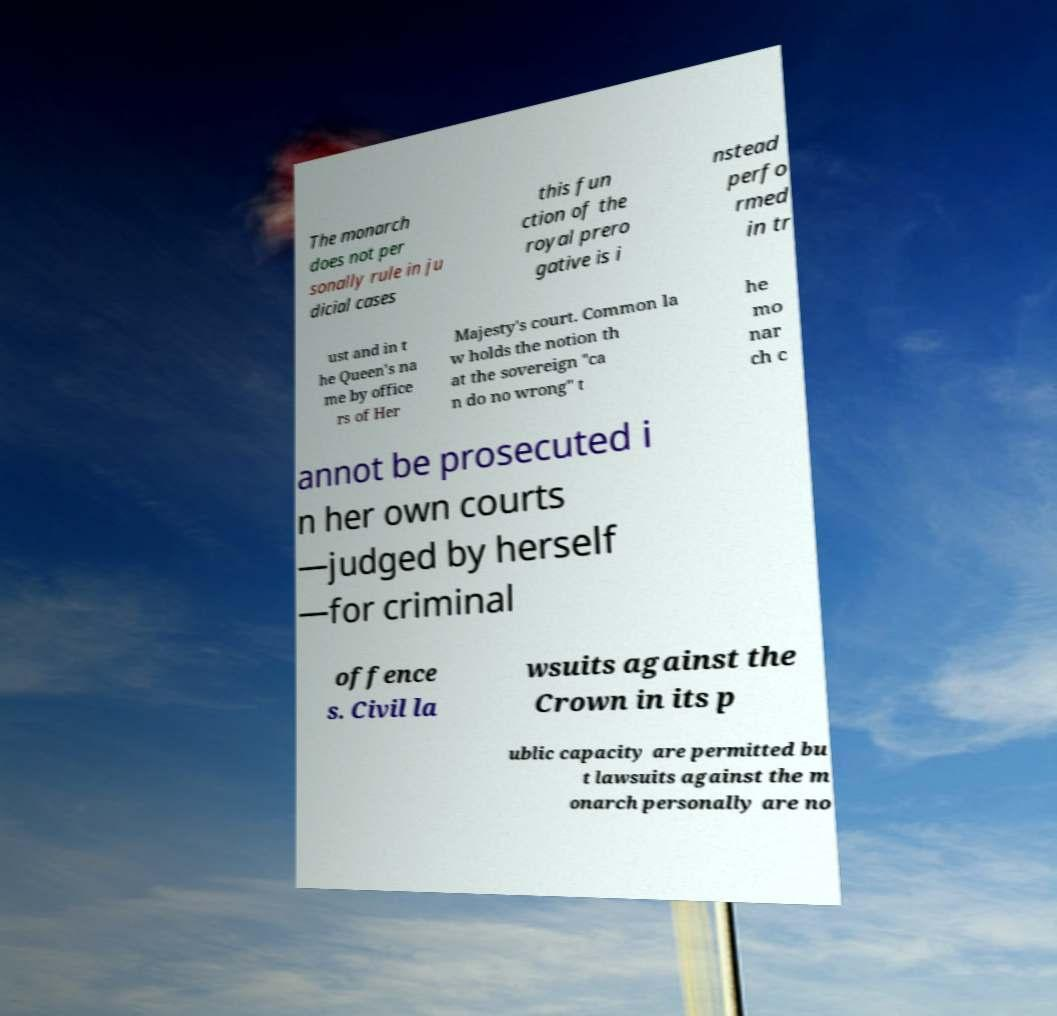I need the written content from this picture converted into text. Can you do that? The monarch does not per sonally rule in ju dicial cases this fun ction of the royal prero gative is i nstead perfo rmed in tr ust and in t he Queen's na me by office rs of Her Majesty's court. Common la w holds the notion th at the sovereign "ca n do no wrong" t he mo nar ch c annot be prosecuted i n her own courts —judged by herself —for criminal offence s. Civil la wsuits against the Crown in its p ublic capacity are permitted bu t lawsuits against the m onarch personally are no 